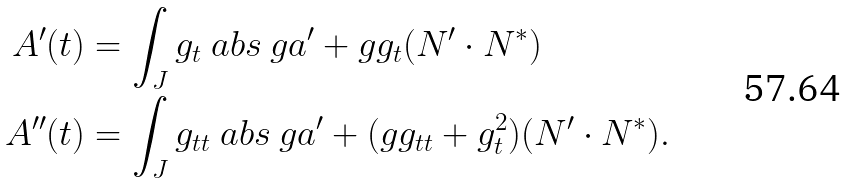<formula> <loc_0><loc_0><loc_500><loc_500>A ^ { \prime } ( t ) & = \int _ { J } g _ { t } \ a b s { \ g a ^ { \prime } } + g g _ { t } ( N ^ { \prime } \cdot N ^ { * } ) \\ A ^ { \prime \prime } ( t ) & = \int _ { J } g _ { t t } \ a b s { \ g a ^ { \prime } } + ( g g _ { t t } + g _ { t } ^ { 2 } ) ( N ^ { \prime } \cdot N ^ { * } ) .</formula> 